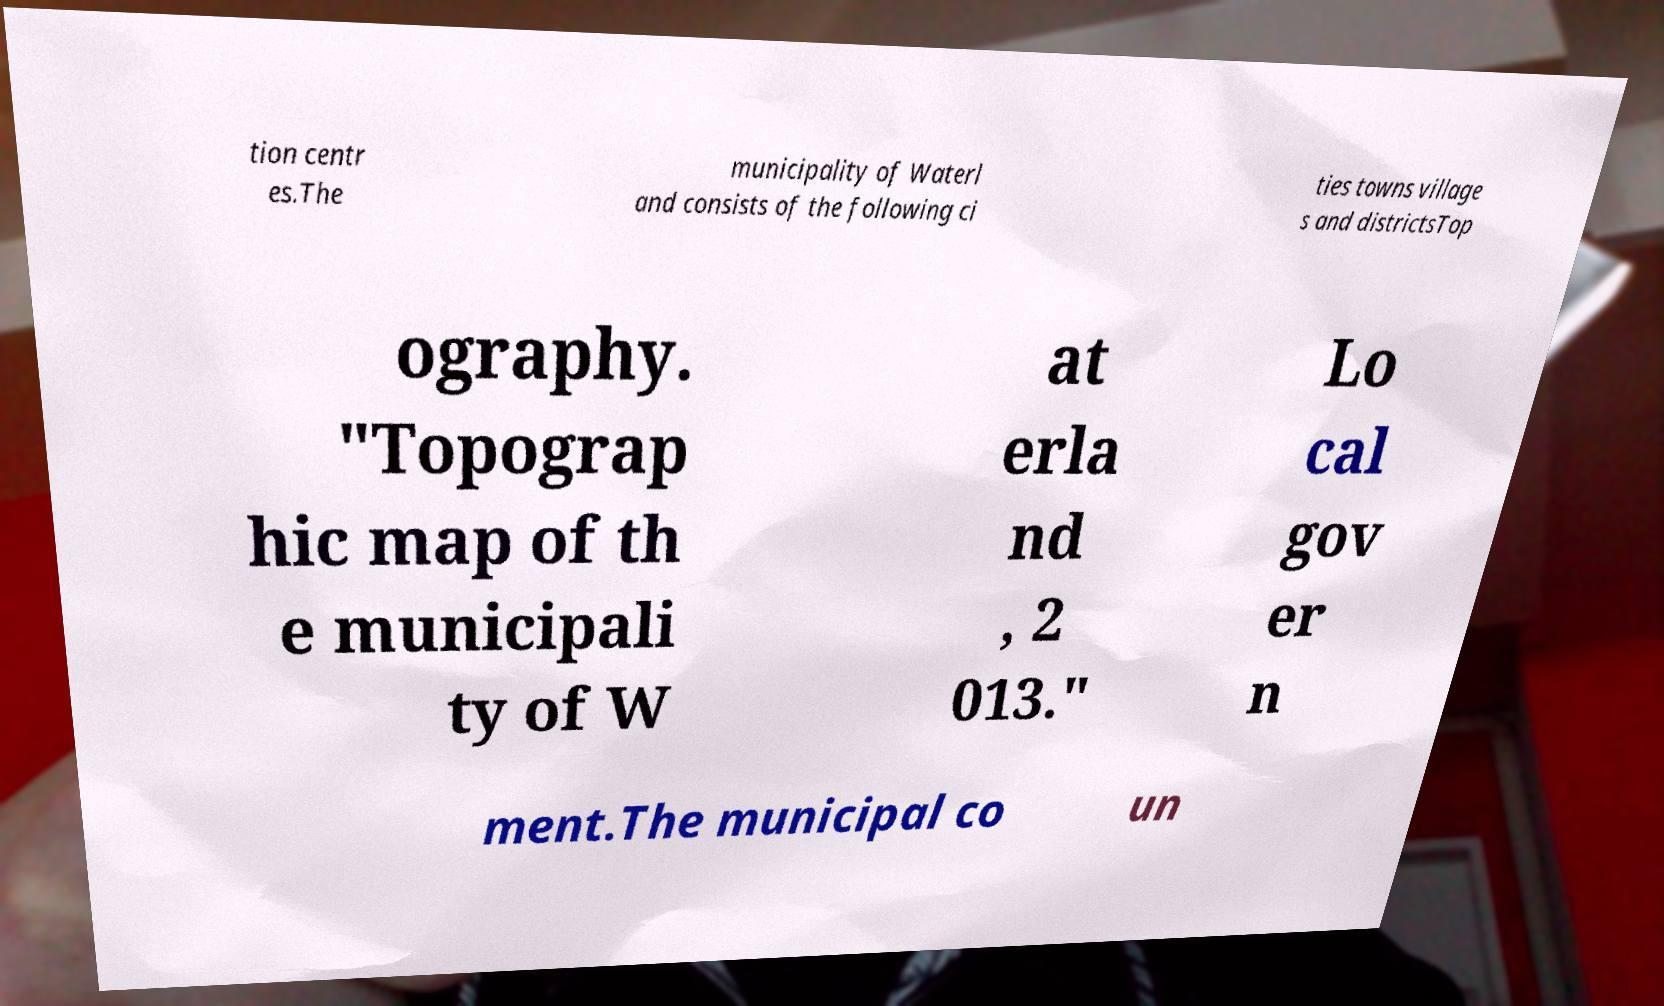Could you assist in decoding the text presented in this image and type it out clearly? tion centr es.The municipality of Waterl and consists of the following ci ties towns village s and districtsTop ography. "Topograp hic map of th e municipali ty of W at erla nd , 2 013." Lo cal gov er n ment.The municipal co un 